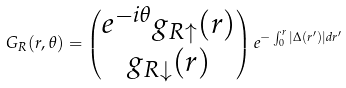Convert formula to latex. <formula><loc_0><loc_0><loc_500><loc_500>G _ { R } ( r , \theta ) = \begin{pmatrix} e ^ { - i \theta } g _ { R \uparrow } ( r ) \\ g _ { R \downarrow } ( r ) \end{pmatrix} e ^ { - \int _ { 0 } ^ { r } | \Delta ( r ^ { \prime } ) | d r ^ { \prime } }</formula> 